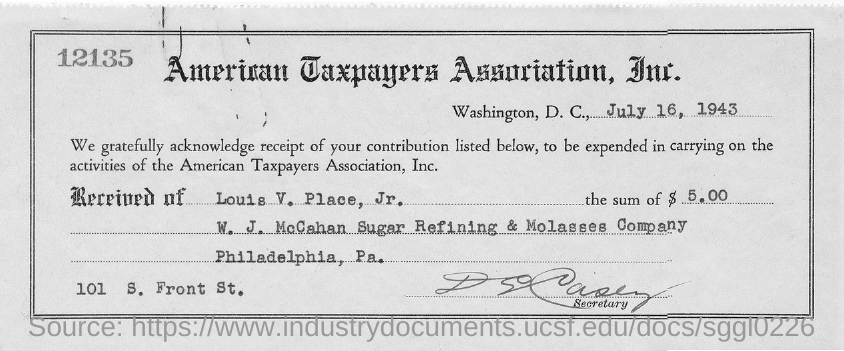Mention a couple of crucial points in this snapshot. The receipt number printed at the left top corner of the receipt is 12135. The American Taxpayers Association, Inc. is located in Washington, D.C. The receipt was given on July 16, 1943. The receipt was given by the American Taxpayers Association, Inc. The Secretary has signed the receipt. 